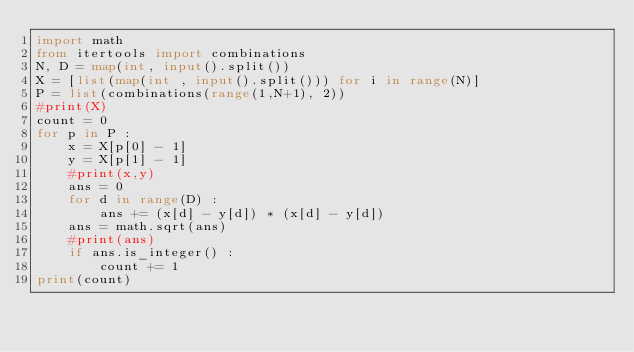Convert code to text. <code><loc_0><loc_0><loc_500><loc_500><_Python_>import math
from itertools import combinations
N, D = map(int, input().split())
X = [list(map(int , input().split())) for i in range(N)]
P = list(combinations(range(1,N+1), 2))
#print(X)
count = 0
for p in P :
    x = X[p[0] - 1]
    y = X[p[1] - 1]
    #print(x,y)
    ans = 0
    for d in range(D) :
        ans += (x[d] - y[d]) * (x[d] - y[d])
    ans = math.sqrt(ans)
    #print(ans)
    if ans.is_integer() :
        count += 1
print(count)
</code> 